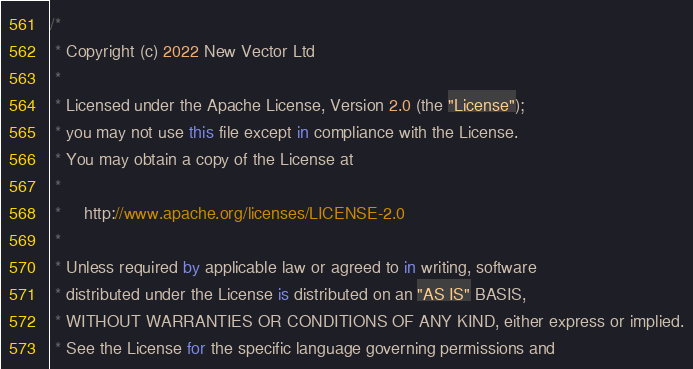<code> <loc_0><loc_0><loc_500><loc_500><_Kotlin_>/*
 * Copyright (c) 2022 New Vector Ltd
 *
 * Licensed under the Apache License, Version 2.0 (the "License");
 * you may not use this file except in compliance with the License.
 * You may obtain a copy of the License at
 *
 *     http://www.apache.org/licenses/LICENSE-2.0
 *
 * Unless required by applicable law or agreed to in writing, software
 * distributed under the License is distributed on an "AS IS" BASIS,
 * WITHOUT WARRANTIES OR CONDITIONS OF ANY KIND, either express or implied.
 * See the License for the specific language governing permissions and</code> 